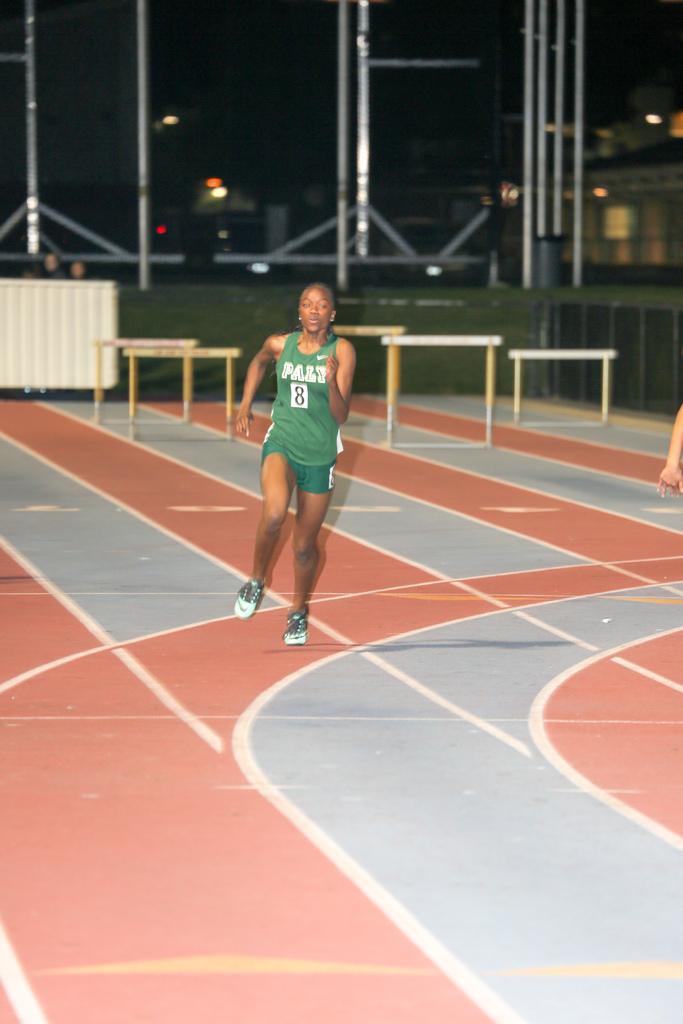Can you describe this image briefly? In this image we can see an athlete. In the background there are iron grills, walls, sky and electric lights. 